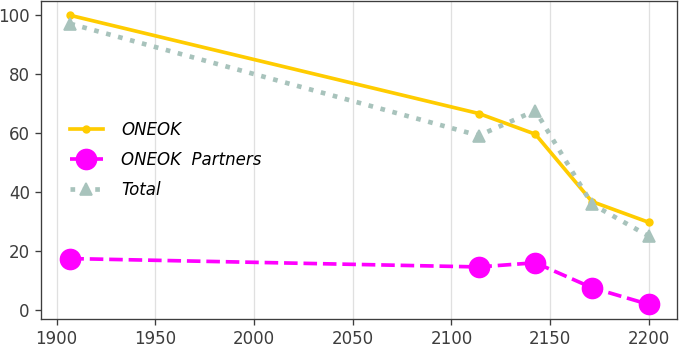Convert chart. <chart><loc_0><loc_0><loc_500><loc_500><line_chart><ecel><fcel>ONEOK<fcel>ONEOK  Partners<fcel>Total<nl><fcel>1906.96<fcel>99.81<fcel>17.31<fcel>96.96<nl><fcel>2113.83<fcel>66.52<fcel>14.47<fcel>59.04<nl><fcel>2142.49<fcel>59.5<fcel>15.89<fcel>67.51<nl><fcel>2171.15<fcel>36.65<fcel>7.42<fcel>35.79<nl><fcel>2199.81<fcel>29.63<fcel>1.78<fcel>24.94<nl></chart> 